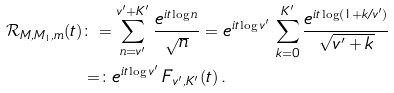Convert formula to latex. <formula><loc_0><loc_0><loc_500><loc_500>\mathcal { R } _ { M , M _ { 1 } , m } ( t ) & \colon = \sum _ { n = v ^ { \prime } } ^ { v ^ { \prime } + K ^ { \prime } } \frac { e ^ { i t \log n } } { \sqrt { n } } = e ^ { i t \log v ^ { \prime } } \, \sum _ { k = 0 } ^ { K ^ { \prime } } \frac { e ^ { i t \log ( 1 + k / v ^ { \prime } ) } } { \sqrt { v ^ { \prime } + k } } \\ & = \colon e ^ { i t \log v ^ { \prime } } \, F _ { v ^ { \prime } , K ^ { \prime } } ( t ) \, .</formula> 